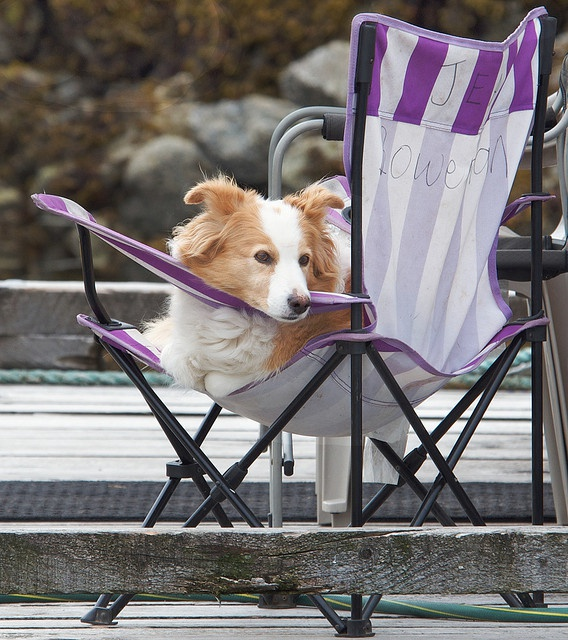Describe the objects in this image and their specific colors. I can see chair in black, lightgray, gray, and darkgray tones and dog in black, lightgray, darkgray, tan, and gray tones in this image. 